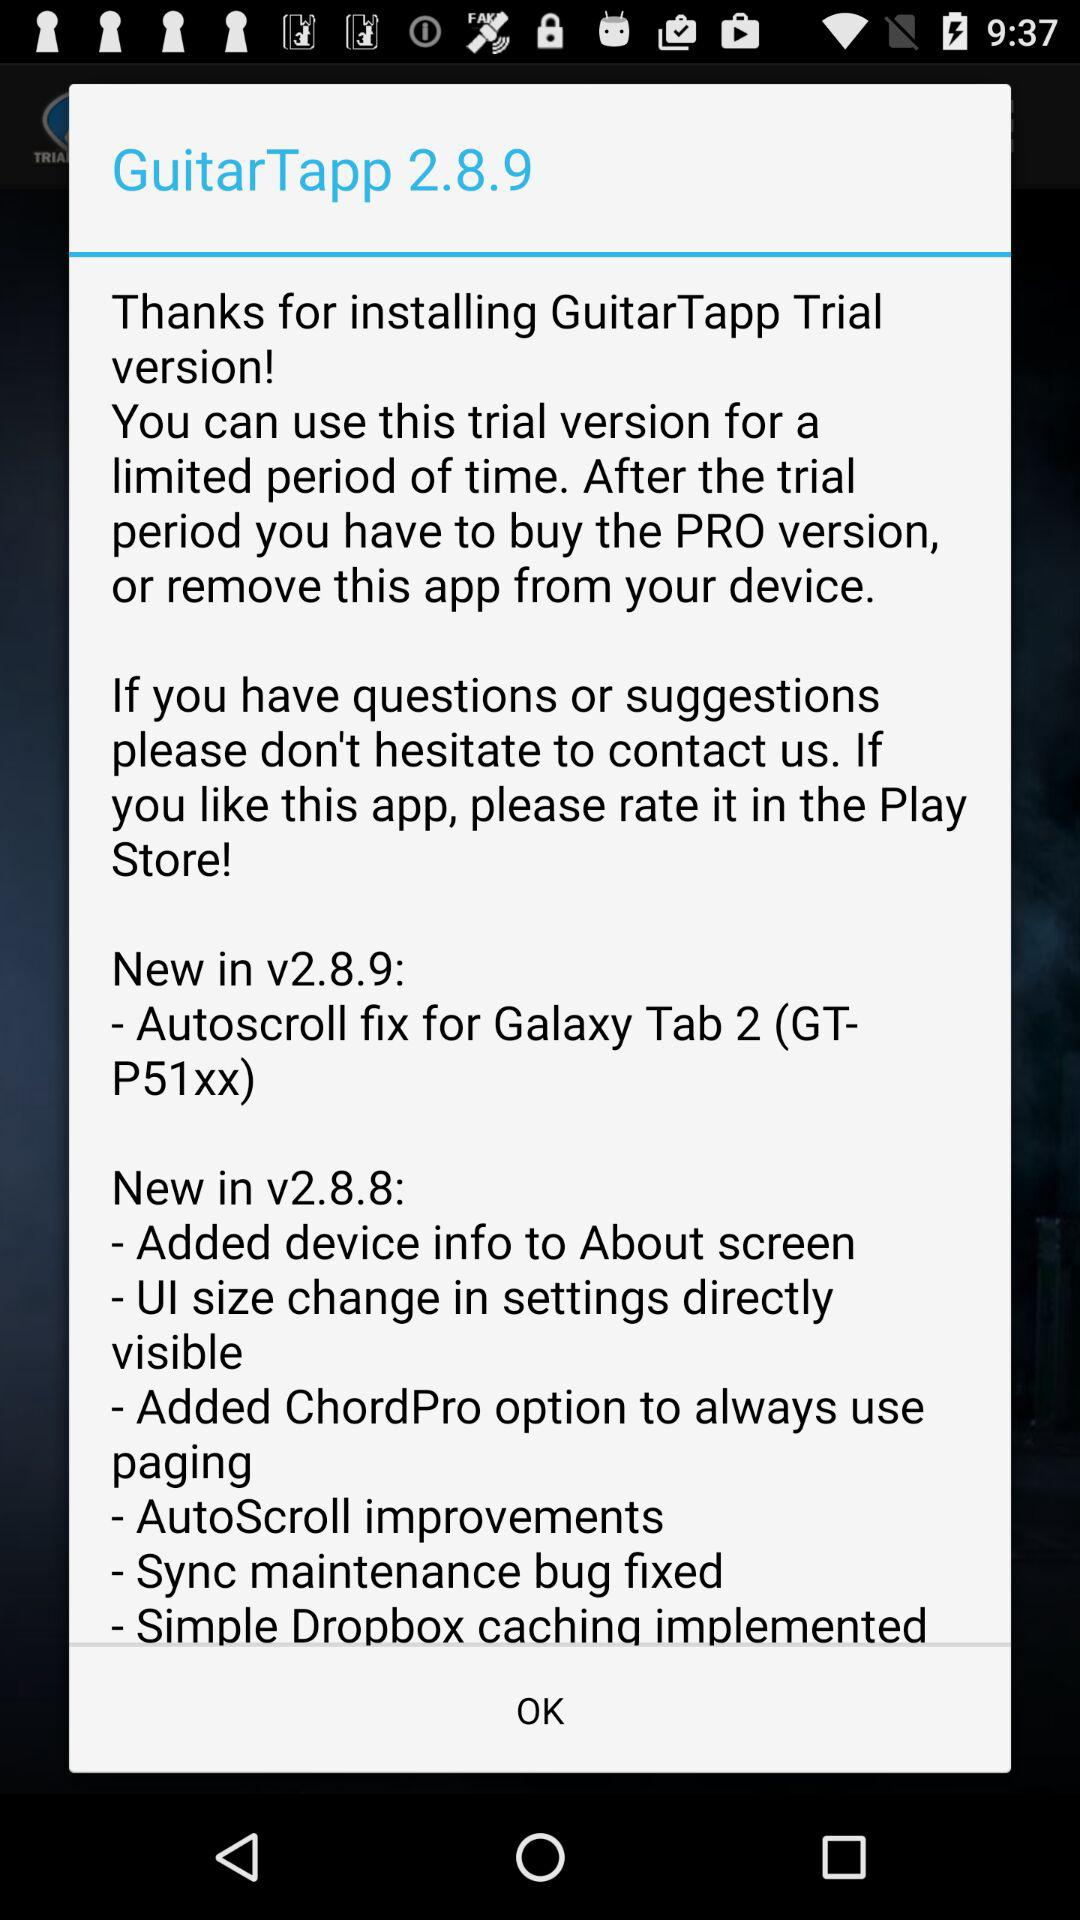What is the new update in version number 2.8.9? The new update in version number 2.8.9 is "- Autoscroll fix for Galaxy Tab 2 (GT- P51xx)". 